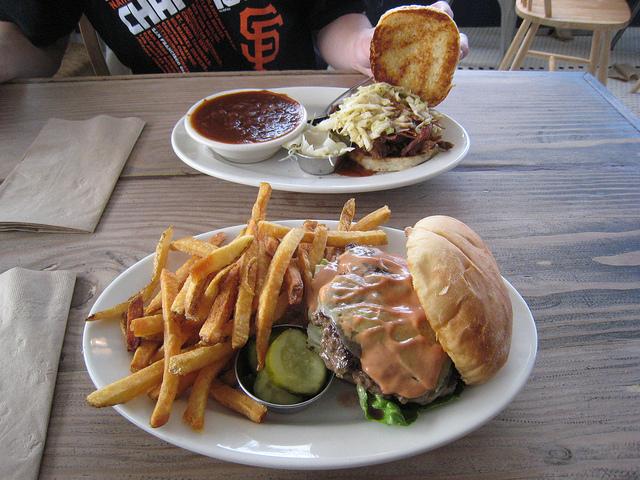Please extract the text content from this image. CHH 